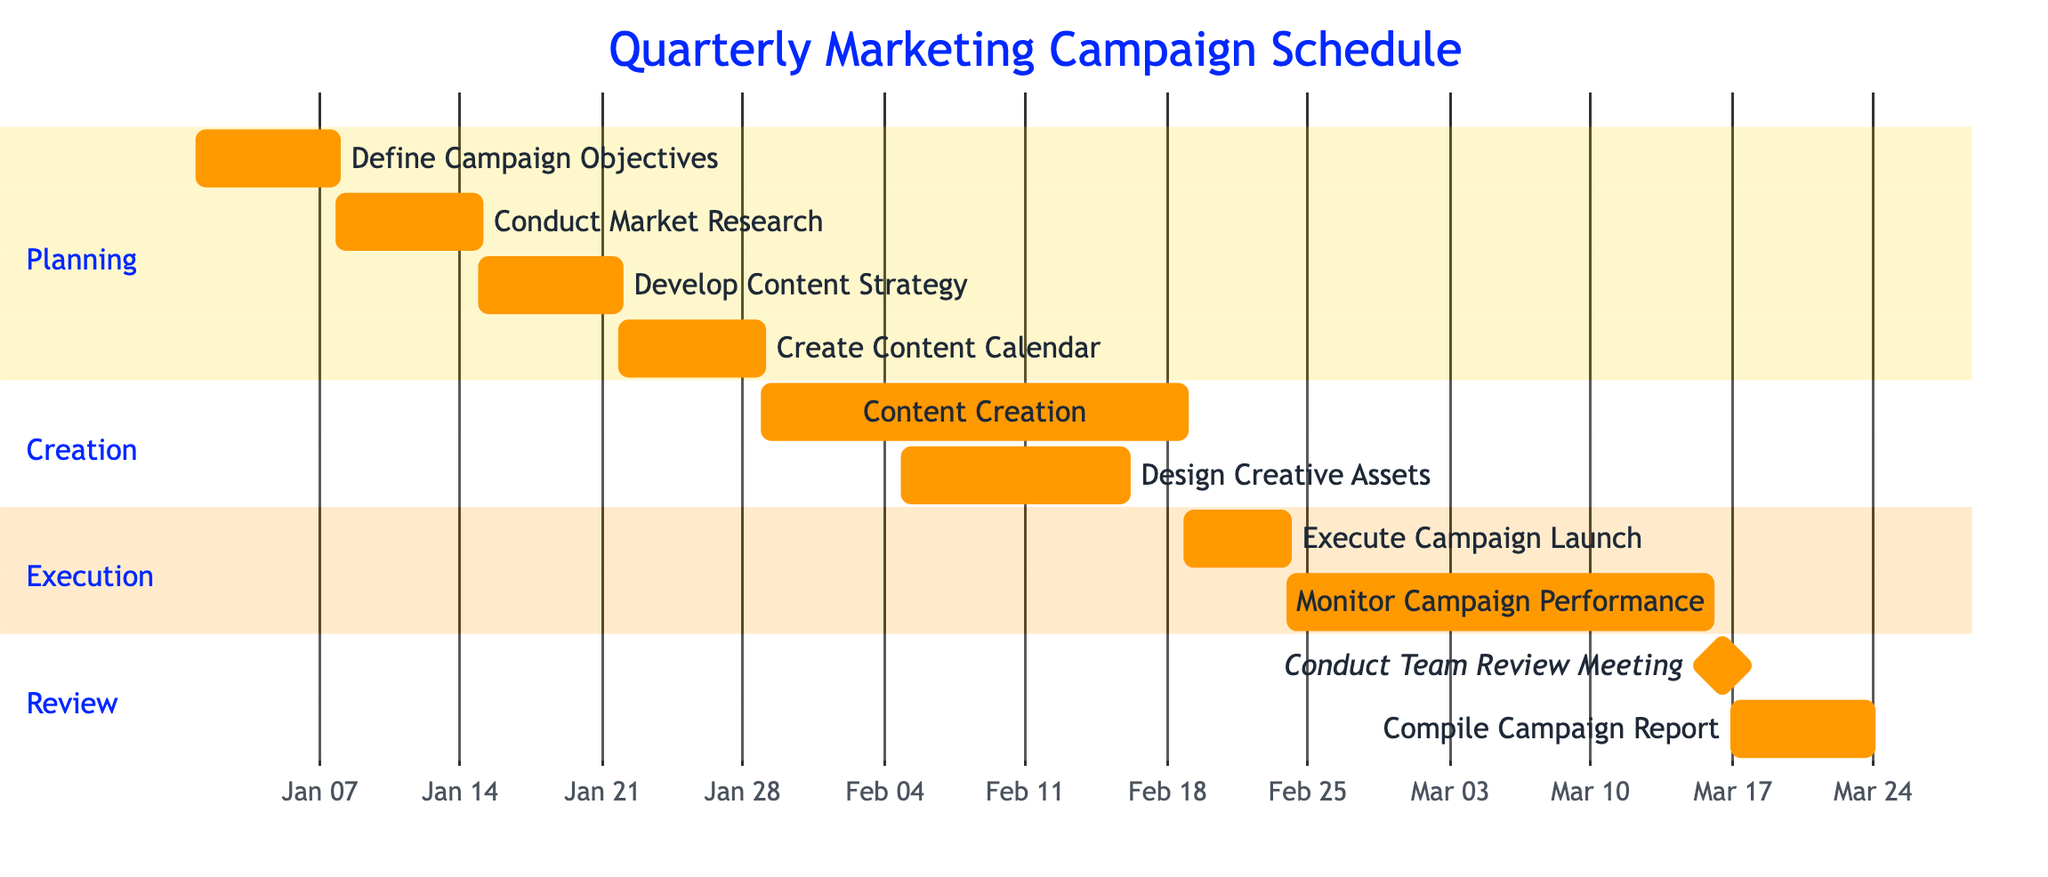What is the total number of tasks in the schedule? Counting each listed task in the Gantt chart, there are 10 individual tasks for the marketing campaign scheduled over the quarter.
Answer: 10 Which task starts on January 8, 2024? Looking at the tasks, "Conduct Market Research" is the task that begins on this date, as provided in the task list.
Answer: Conduct Market Research What is the duration of the "Content Creation" task? The "Content Creation" task spans from January 29 to February 18, inclusive. This totals 21 days of duration.
Answer: 21 days What is the last task in the Review section? The last task in the Review section is "Compile Campaign Report", which appears after "Conduct Team Review Meeting" in the listed tasks.
Answer: Compile Campaign Report During which days is "Monitor Campaign Performance" scheduled? This task is set to occur from February 24 to March 15, covering a continuous range of days specified in the timeline of the Gantt chart.
Answer: February 24 to March 15 Which task overlaps with "Design Creative Assets"? "Content Creation (Blogs, Social Media Posts, Videos)" overlaps with "Design Creative Assets", as both tasks run during early to mid-February concurrently.
Answer: Content Creation What is the milestone date for the "Conduct Team Review Meeting"? The "Conduct Team Review Meeting" is marked as a milestone that takes place on March 16, 2024, which is specified explicitly in the schedule setup.
Answer: March 16 How many days are allocated for executing the campaign launch? The "Execute Campaign Launch" task is scheduled for 5 days, from February 19 to February 23, as reflected in the Gantt chart.
Answer: 5 days Which task follows "Create Content Calendar"? The task that immediately follows "Create Content Calendar" is "Content Creation (Blogs, Social Media Posts, Videos)", showing a direct progression in the schedule.
Answer: Content Creation 